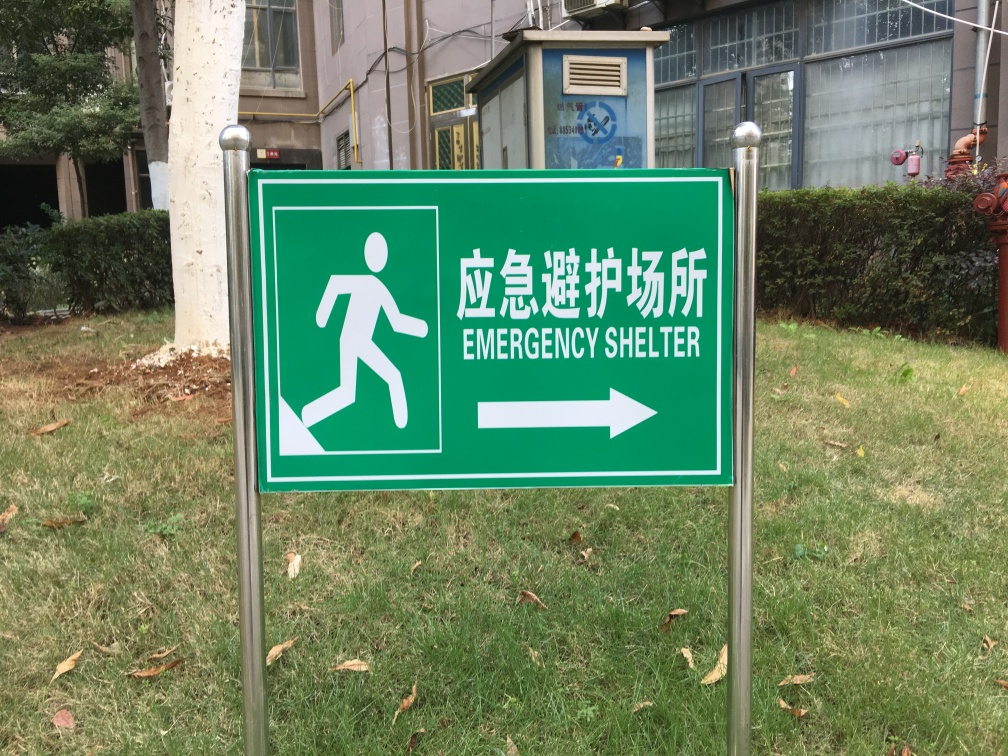Can you provide some context about where this type of sign might be found? Signs like the one in the image are commonly found in public areas and spaces where people gather, such as schools, hospitals, parks, and near public shelters. They are strategically placed to guide individuals to safety during emergencies such as natural disasters, fires, or other crises. 